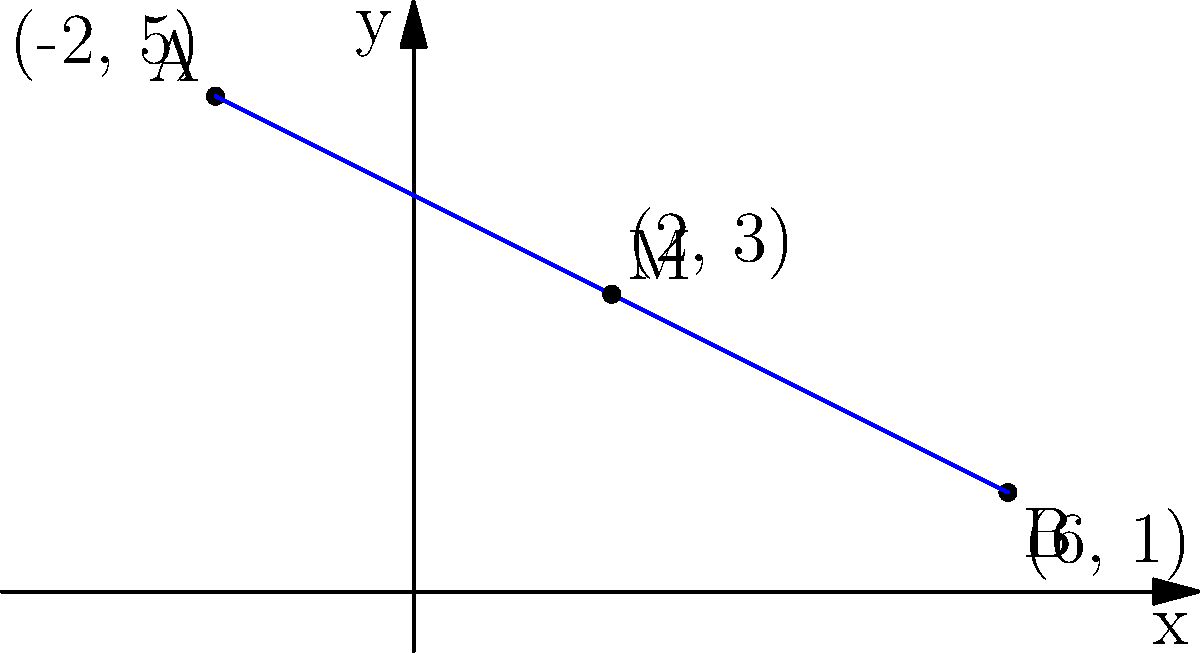Your friend, a talented racer, is analyzing a new track layout. The start line is at point A(-2, 5) and the finish line is at point B(6, 1) on a coordinate plane. To place a checkpoint, you need to find the midpoint M of the line segment AB. What are the coordinates of point M? To find the midpoint of a line segment, we can use the midpoint formula:

$$ M_x = \frac{x_1 + x_2}{2}, \quad M_y = \frac{y_1 + y_2}{2} $$

Where $(x_1, y_1)$ are the coordinates of point A, and $(x_2, y_2)$ are the coordinates of point B.

Step 1: Identify the coordinates
A: $(-2, 5)$
B: $(6, 1)$

Step 2: Calculate the x-coordinate of the midpoint
$$ M_x = \frac{x_1 + x_2}{2} = \frac{-2 + 6}{2} = \frac{4}{2} = 2 $$

Step 3: Calculate the y-coordinate of the midpoint
$$ M_y = \frac{y_1 + y_2}{2} = \frac{5 + 1}{2} = \frac{6}{2} = 3 $$

Step 4: Combine the results
The midpoint M has coordinates $(2, 3)$.
Answer: $(2, 3)$ 